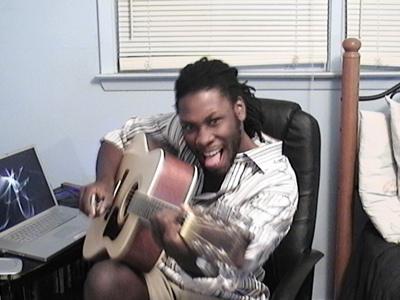Is the man happy?
Short answer required. Yes. What instrument is shown?
Keep it brief. Guitar. Does the man have curly hair?
Answer briefly. Yes. 